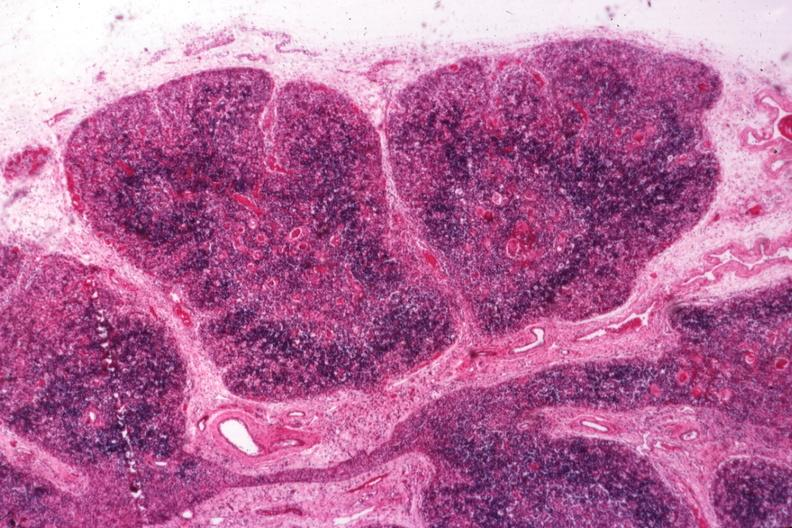s opened uterus and cervix with large cervical myoma protruding into vagina slide present?
Answer the question using a single word or phrase. No 